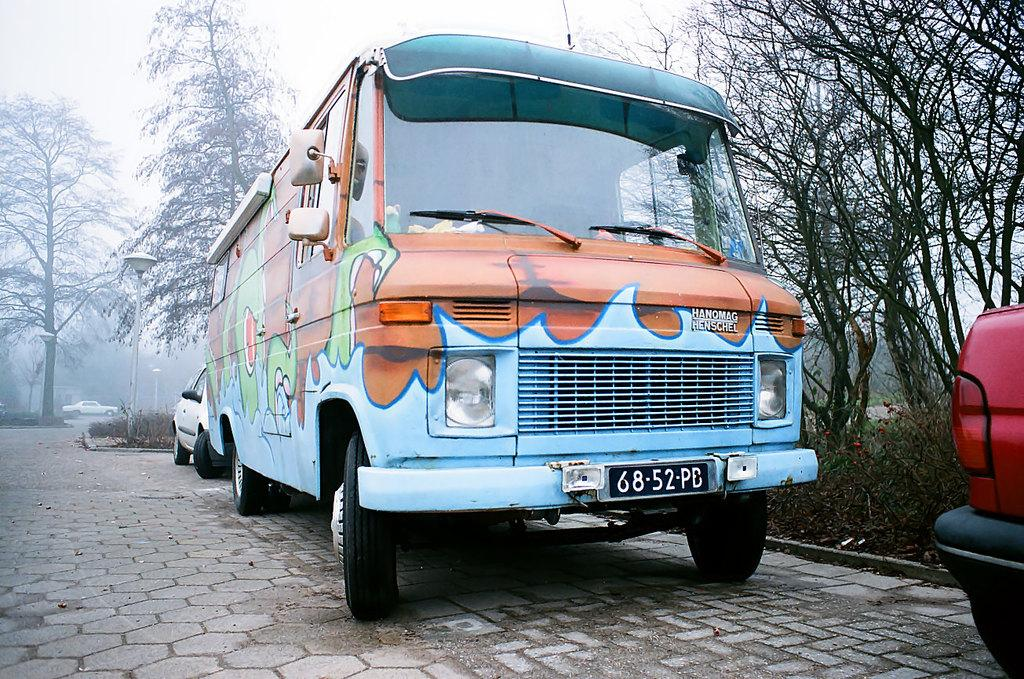Provide a one-sentence caption for the provided image. An old school bus painted light blue with a orange and green design on it. 